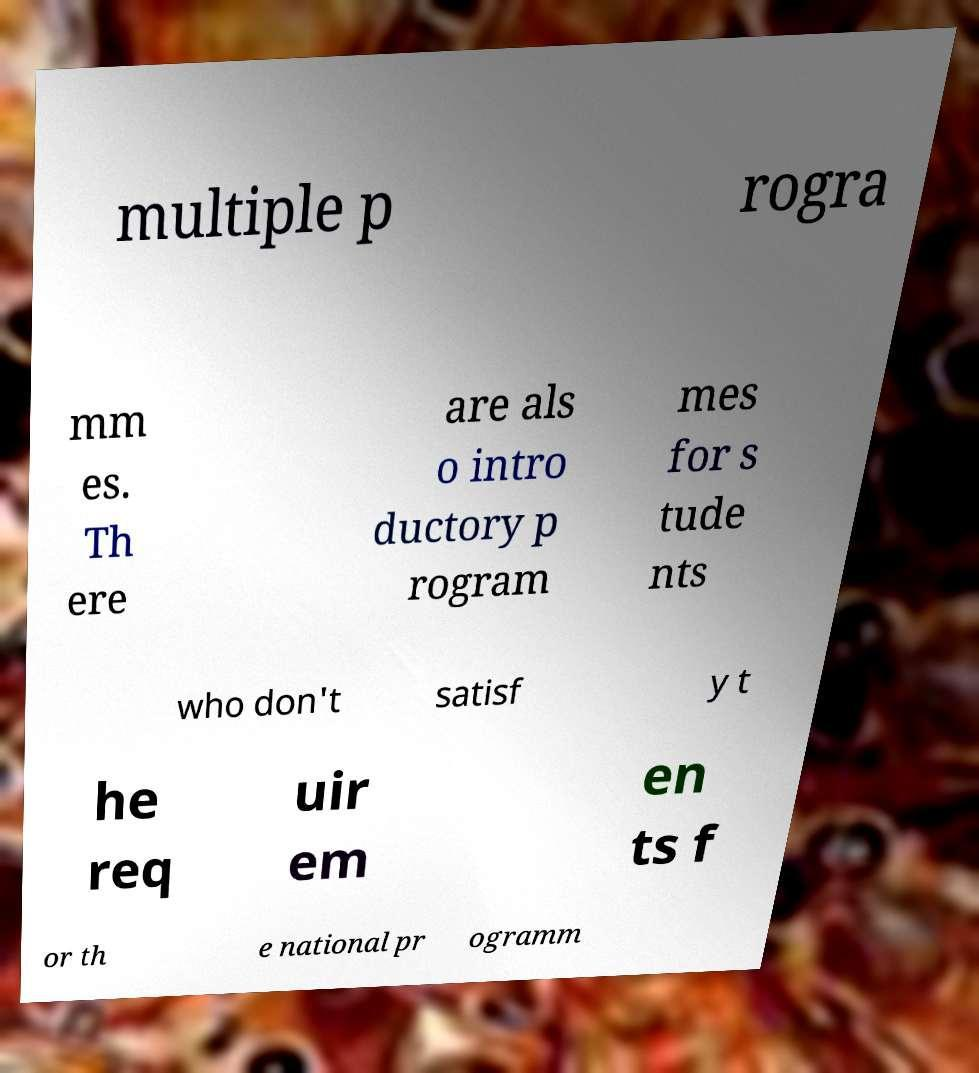There's text embedded in this image that I need extracted. Can you transcribe it verbatim? multiple p rogra mm es. Th ere are als o intro ductory p rogram mes for s tude nts who don't satisf y t he req uir em en ts f or th e national pr ogramm 